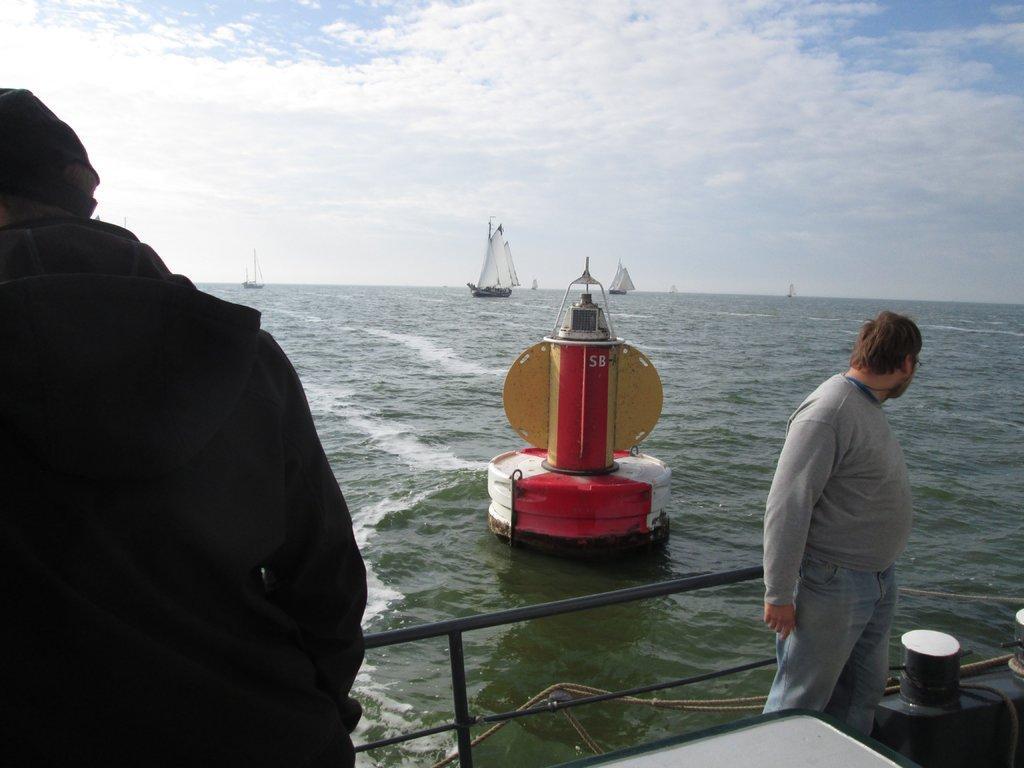In one or two sentences, can you explain what this image depicts? In this picture I can see some boats on the water. In the center there is a man who is sitting on this rocket shaped. On the right there is a man who is standing near to the fencing. On the left there is another man who is wearing jacket and cap. At the top I can see the sky and clouds. 